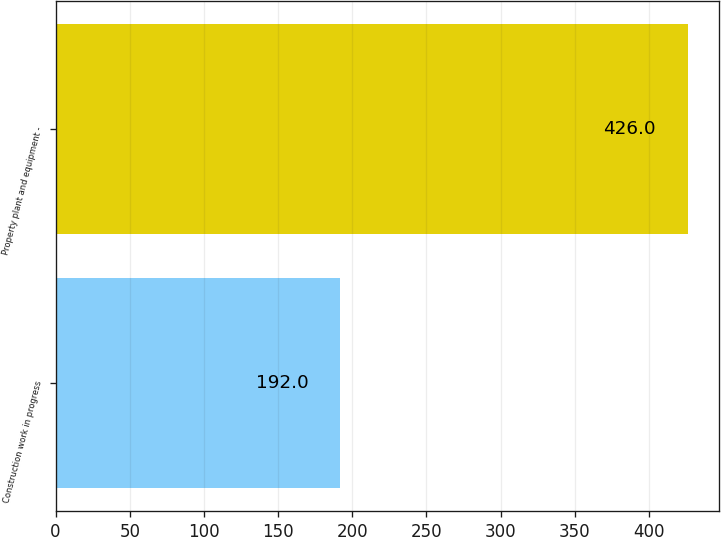Convert chart. <chart><loc_0><loc_0><loc_500><loc_500><bar_chart><fcel>Construction work in progress<fcel>Property plant and equipment -<nl><fcel>192<fcel>426<nl></chart> 